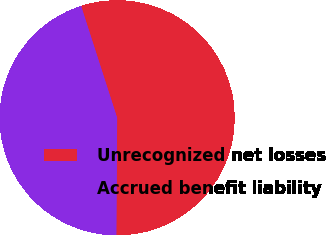Convert chart to OTSL. <chart><loc_0><loc_0><loc_500><loc_500><pie_chart><fcel>Unrecognized net losses<fcel>Accrued benefit liability<nl><fcel>55.07%<fcel>44.93%<nl></chart> 